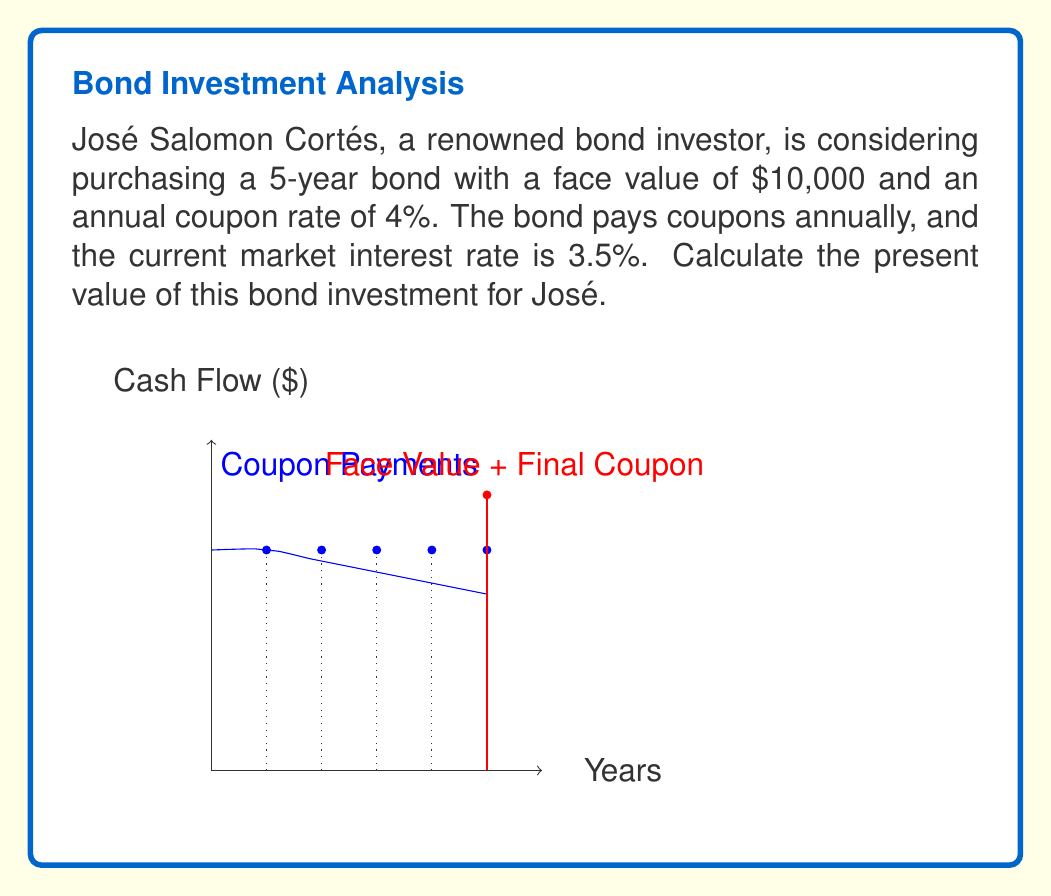Could you help me with this problem? To calculate the present value of the bond, we need to discount all future cash flows to the present. This includes the annual coupon payments and the face value repayment at maturity.

1) First, let's identify the cash flows:
   - Annual coupon payment = Face value × Coupon rate
   $$400 = $10,000 \times 4\%$$
   - Face value repayment at maturity = $10,000

2) Now, we'll calculate the present value of each cash flow using the formula:
   $$PV = \frac{CF}{(1+r)^t}$$
   where CF is the cash flow, r is the discount rate, and t is the time in years.

3) For the coupon payments:
   Year 1: $$PV_1 = \frac{400}{(1+0.035)^1} = 386.47$$
   Year 2: $$PV_2 = \frac{400}{(1+0.035)^2} = 373.40$$
   Year 3: $$PV_3 = \frac{400}{(1+0.035)^3} = 360.77$$
   Year 4: $$PV_4 = \frac{400}{(1+0.035)^4} = 348.57$$
   Year 5: $$PV_5 = \frac{400}{(1+0.035)^5} = 336.78$$

4) For the face value repayment at maturity (Year 5):
   $$PV_{face} = \frac{10,000}{(1+0.035)^5} = 8,419.47$$

5) The total present value is the sum of all these components:
   $$PV_{total} = 386.47 + 373.40 + 360.77 + 348.57 + 336.78 + 8,419.47 = 10,225.46$$

Therefore, the present value of José Salomon Cortés' bond investment is $10,225.46.
Answer: $10,225.46 